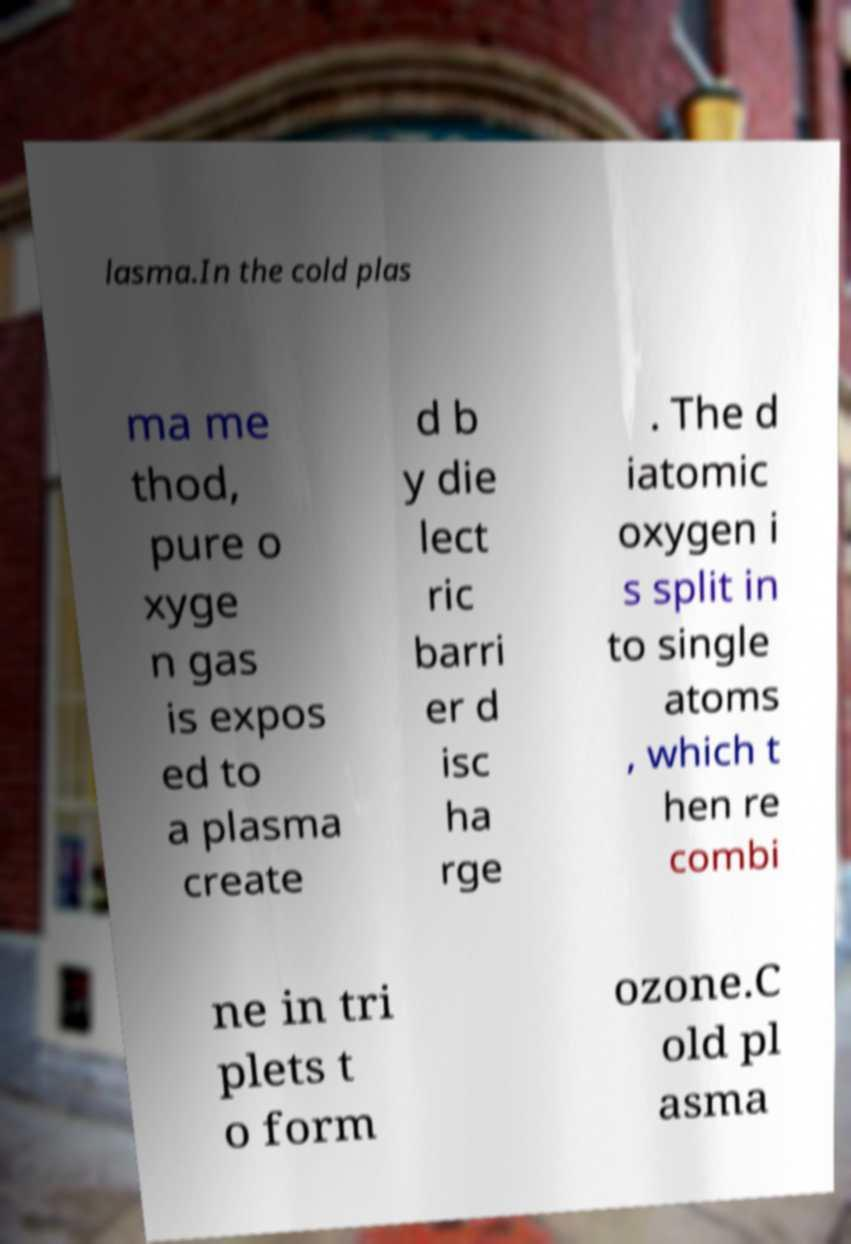Can you accurately transcribe the text from the provided image for me? lasma.In the cold plas ma me thod, pure o xyge n gas is expos ed to a plasma create d b y die lect ric barri er d isc ha rge . The d iatomic oxygen i s split in to single atoms , which t hen re combi ne in tri plets t o form ozone.C old pl asma 